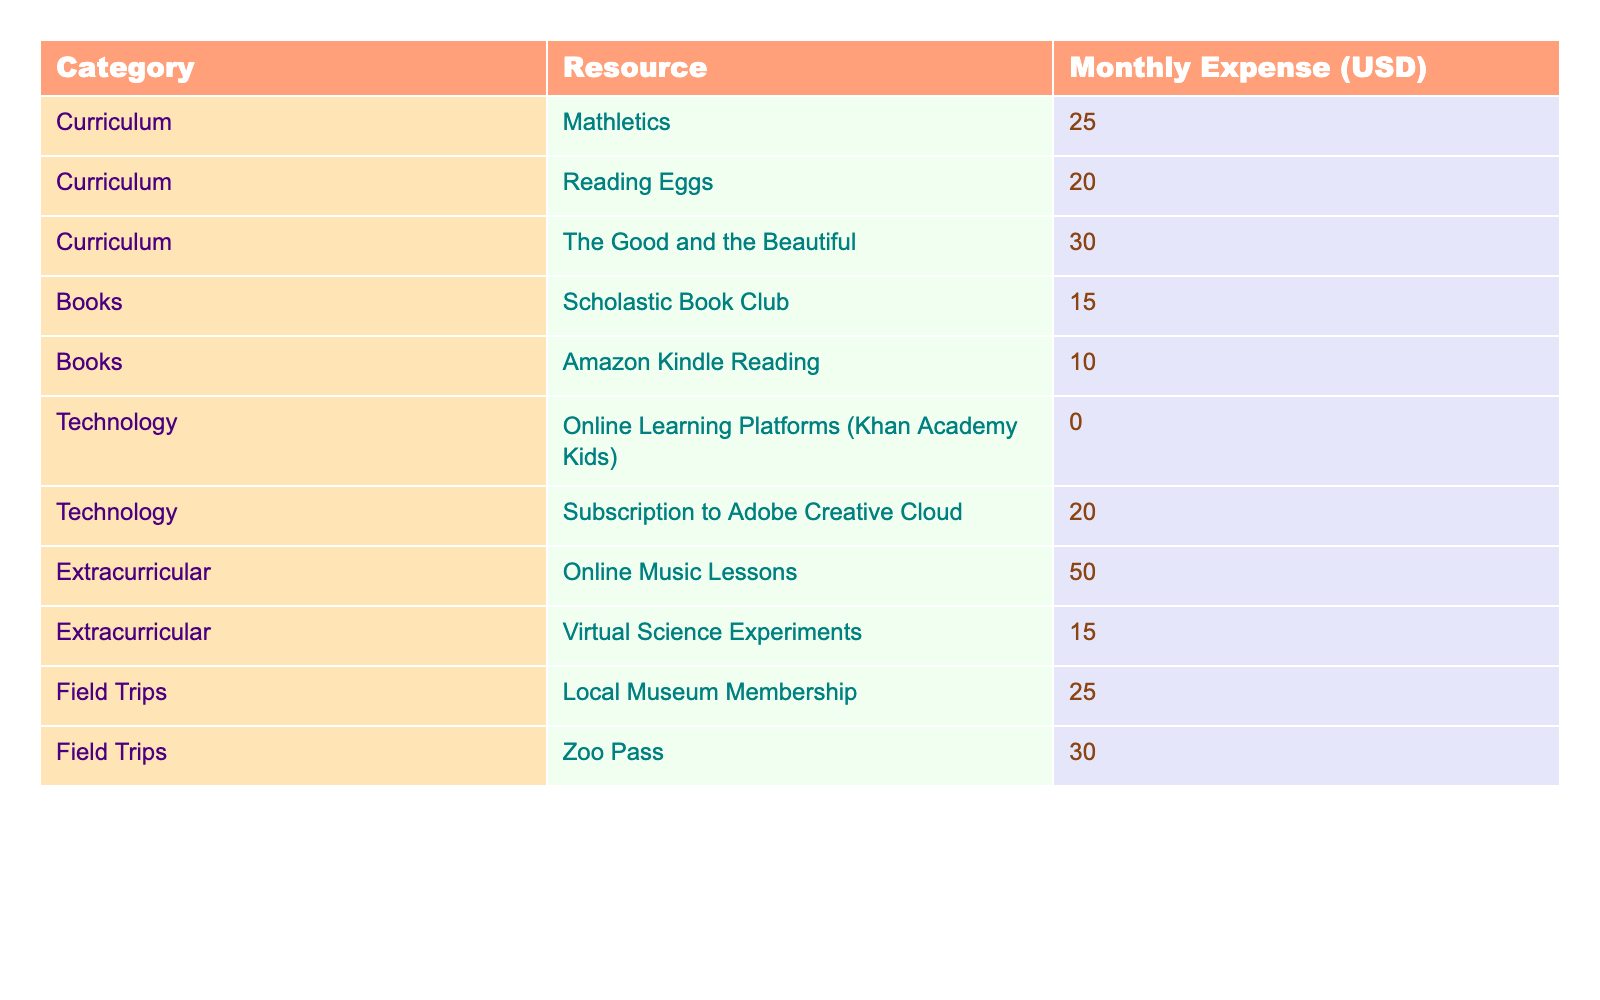What is the total monthly expense for curriculum resources? From the table, I will add the monthly expenses for the curriculum resources: Mathletics (25.00) + Reading Eggs (20.00) + The Good and the Beautiful (30.00) = 75.00
Answer: 75.00 What is the lowest monthly expense among the listed resources? By looking through the expenses, the minimum is for Online Learning Platforms (0.00), as it's the lowest value listed in the table.
Answer: 0.00 How much do extracurricular activities cost each month in total? I will sum the monthly expenses for extracurricular resources: Online Music Lessons (50.00) + Virtual Science Experiments (15.00) = 65.00
Answer: 65.00 Is there a resource that has a monthly expense of 30.00? Checking the table, The Good and the Beautiful (30.00) and Zoo Pass (30.00) have the value of 30.00 listed. Therefore, this statement is true.
Answer: Yes What is the average monthly expense for all field trip resources? The field trip expenses are Local Museum Membership (25.00) and Zoo Pass (30.00). The total is 25.00 + 30.00 = 55.00. There are 2 field trip resources, so the average is 55.00 / 2 = 27.50.
Answer: 27.50 What is the combined monthly expense for books and technology resources? First, add the monthly expenses for books: Scholastic Book Club (15.00) + Amazon Kindle Reading (10.00) = 25.00. Then, add the technology expenses: Online Learning Platforms (0.00) + Subscription to Adobe Creative Cloud (20.00) = 20.00. Finally, combine these totals: 25.00 + 20.00 = 45.00.
Answer: 45.00 Which category has the highest monthly expense in a single resource? Looking through the expenses, the highest single resource expense is Online Music Lessons under Extracurricular at 50.00, which is higher than any other resource.
Answer: Extracurricular What is the difference in monthly expense between the most and least expensive curriculum resource? The most expensive curriculum resource is The Good and the Beautiful at 30.00, and the least expensive is Reading Eggs at 20.00. The difference is 30.00 - 20.00 = 10.00.
Answer: 10.00 What percentage of the total monthly expenses is spent on extracurricular resources? First, total all monthly expenses: 25.00 + 20.00 + 30.00 + 15.00 + 10.00 + 0.00 + 20.00 + 50.00 + 15.00 + 25.00 + 30.00 = 225.00. The extracurricular total is 65.00 as calculated previously. The percentage is (65.00 / 225.00) * 100 = approximately 28.89%.
Answer: Approximately 28.89% What is the total monthly expense on educational resources if only technology is considered? The technology monthly expenses are Online Learning Platforms (0.00) and Subscription to Adobe Creative Cloud (20.00). Therefore, the total is 0.00 + 20.00 = 20.00.
Answer: 20.00 